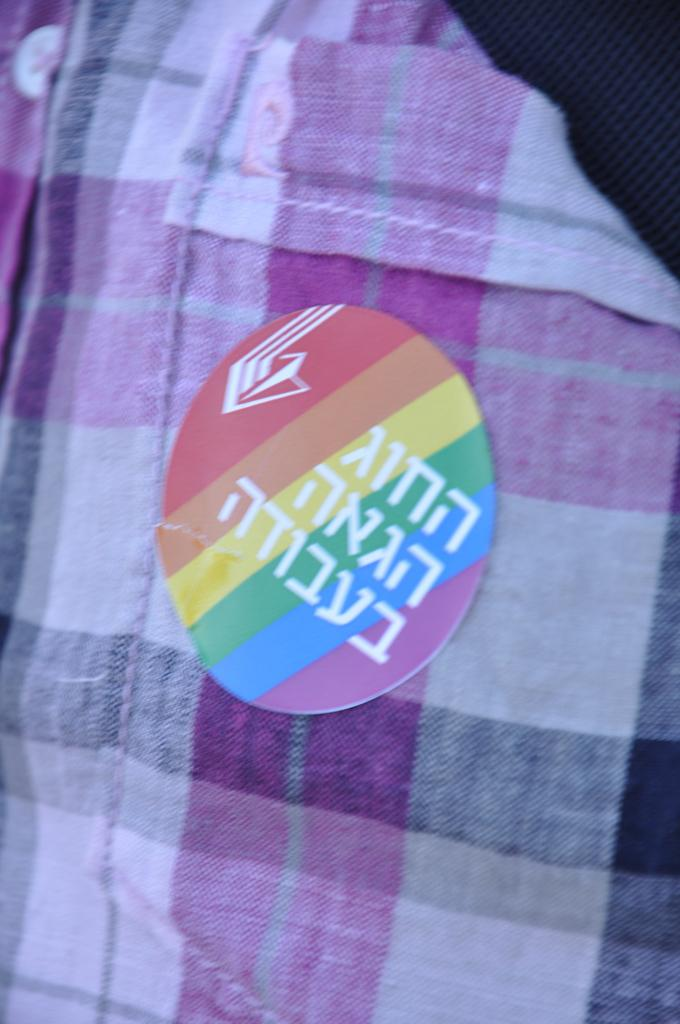What is present on the cloth in the image? There is a sticker on the cloth. Can you describe the cloth in the image? The cloth is the main subject in the image, and it has a sticker on it. What type of horn is being played by the turkey in the image? There is no turkey or horn present in the image; it only features a cloth with a sticker on it. 